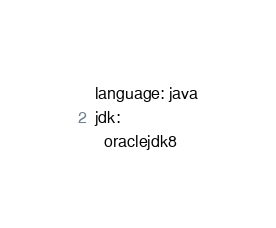Convert code to text. <code><loc_0><loc_0><loc_500><loc_500><_YAML_>language: java
jdk:
  oraclejdk8</code> 